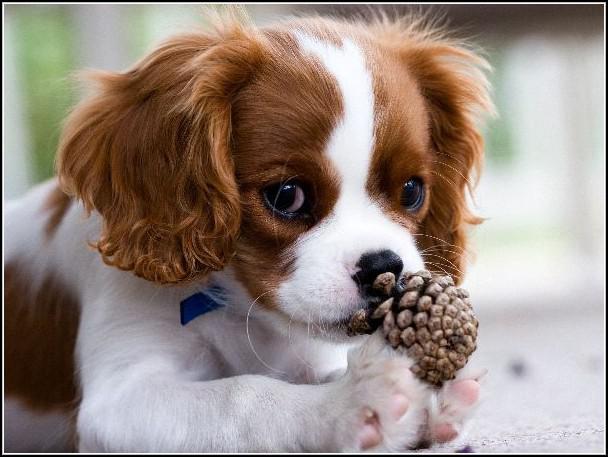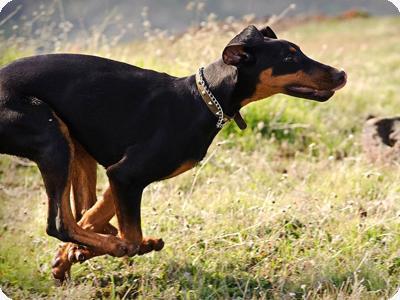The first image is the image on the left, the second image is the image on the right. Given the left and right images, does the statement "There are three dogs in total." hold true? Answer yes or no. No. The first image is the image on the left, the second image is the image on the right. Given the left and right images, does the statement "There are three dogs." hold true? Answer yes or no. No. 